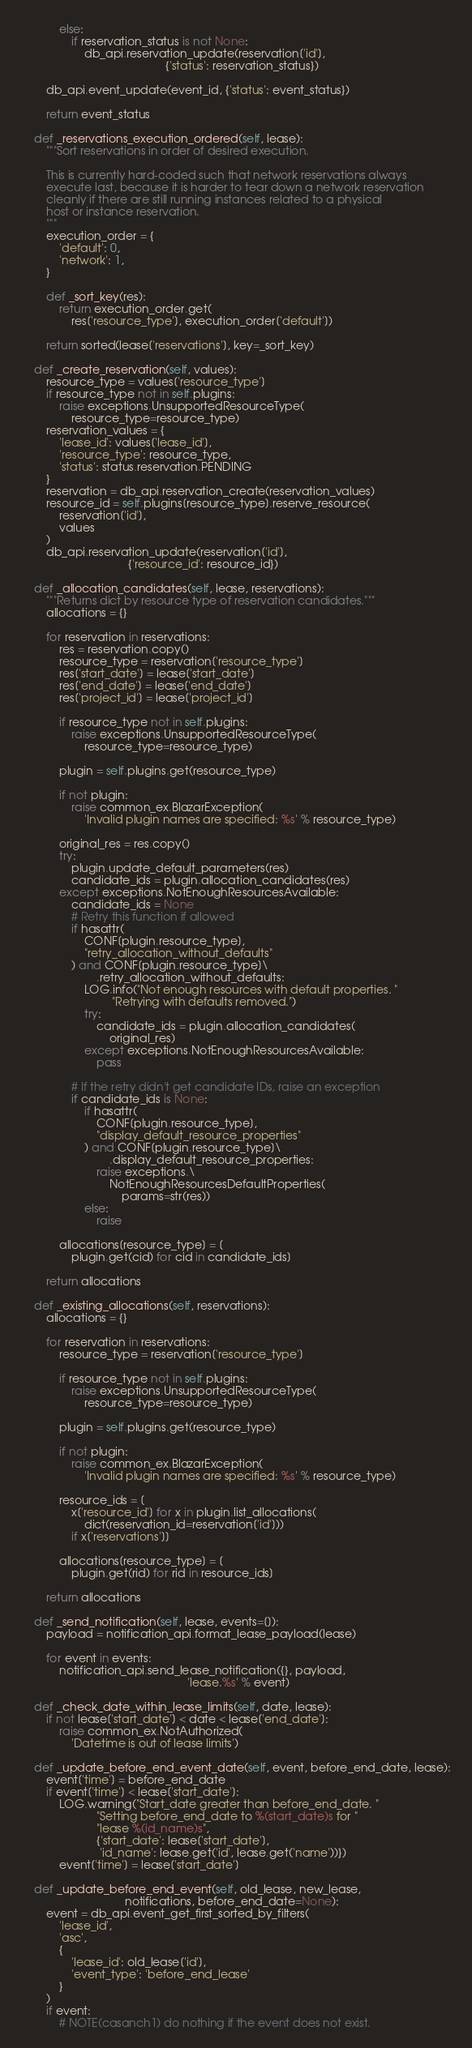Convert code to text. <code><loc_0><loc_0><loc_500><loc_500><_Python_>            else:
                if reservation_status is not None:
                    db_api.reservation_update(reservation['id'],
                                              {'status': reservation_status})

        db_api.event_update(event_id, {'status': event_status})

        return event_status

    def _reservations_execution_ordered(self, lease):
        """Sort reservations in order of desired execution.

        This is currently hard-coded such that network reservations always
        execute last, because it is harder to tear down a network reservation
        cleanly if there are still running instances related to a physical
        host or instance reservation.
        """
        execution_order = {
            'default': 0,
            'network': 1,
        }

        def _sort_key(res):
            return execution_order.get(
                res['resource_type'], execution_order['default'])

        return sorted(lease['reservations'], key=_sort_key)

    def _create_reservation(self, values):
        resource_type = values['resource_type']
        if resource_type not in self.plugins:
            raise exceptions.UnsupportedResourceType(
                resource_type=resource_type)
        reservation_values = {
            'lease_id': values['lease_id'],
            'resource_type': resource_type,
            'status': status.reservation.PENDING
        }
        reservation = db_api.reservation_create(reservation_values)
        resource_id = self.plugins[resource_type].reserve_resource(
            reservation['id'],
            values
        )
        db_api.reservation_update(reservation['id'],
                                  {'resource_id': resource_id})

    def _allocation_candidates(self, lease, reservations):
        """Returns dict by resource type of reservation candidates."""
        allocations = {}

        for reservation in reservations:
            res = reservation.copy()
            resource_type = reservation['resource_type']
            res['start_date'] = lease['start_date']
            res['end_date'] = lease['end_date']
            res['project_id'] = lease['project_id']

            if resource_type not in self.plugins:
                raise exceptions.UnsupportedResourceType(
                    resource_type=resource_type)

            plugin = self.plugins.get(resource_type)

            if not plugin:
                raise common_ex.BlazarException(
                    'Invalid plugin names are specified: %s' % resource_type)

            original_res = res.copy()
            try:
                plugin.update_default_parameters(res)
                candidate_ids = plugin.allocation_candidates(res)
            except exceptions.NotEnoughResourcesAvailable:
                candidate_ids = None
                # Retry this function if allowed
                if hasattr(
                    CONF[plugin.resource_type],
                    "retry_allocation_without_defaults"
                ) and CONF[plugin.resource_type]\
                        .retry_allocation_without_defaults:
                    LOG.info("Not enough resources with default properties. "
                             "Retrying with defaults removed.")
                    try:
                        candidate_ids = plugin.allocation_candidates(
                            original_res)
                    except exceptions.NotEnoughResourcesAvailable:
                        pass

                # If the retry didn't get candidate IDs, raise an exception
                if candidate_ids is None:
                    if hasattr(
                        CONF[plugin.resource_type],
                        "display_default_resource_properties"
                    ) and CONF[plugin.resource_type]\
                            .display_default_resource_properties:
                        raise exceptions.\
                            NotEnoughResourcesDefaultProperties(
                                params=str(res))
                    else:
                        raise

            allocations[resource_type] = [
                plugin.get(cid) for cid in candidate_ids]

        return allocations

    def _existing_allocations(self, reservations):
        allocations = {}

        for reservation in reservations:
            resource_type = reservation['resource_type']

            if resource_type not in self.plugins:
                raise exceptions.UnsupportedResourceType(
                    resource_type=resource_type)

            plugin = self.plugins.get(resource_type)

            if not plugin:
                raise common_ex.BlazarException(
                    'Invalid plugin names are specified: %s' % resource_type)

            resource_ids = [
                x['resource_id'] for x in plugin.list_allocations(
                    dict(reservation_id=reservation['id']))
                if x['reservations']]

            allocations[resource_type] = [
                plugin.get(rid) for rid in resource_ids]

        return allocations

    def _send_notification(self, lease, events=[]):
        payload = notification_api.format_lease_payload(lease)

        for event in events:
            notification_api.send_lease_notification({}, payload,
                                                     'lease.%s' % event)

    def _check_date_within_lease_limits(self, date, lease):
        if not lease['start_date'] < date < lease['end_date']:
            raise common_ex.NotAuthorized(
                'Datetime is out of lease limits')

    def _update_before_end_event_date(self, event, before_end_date, lease):
        event['time'] = before_end_date
        if event['time'] < lease['start_date']:
            LOG.warning("Start_date greater than before_end_date. "
                        "Setting before_end_date to %(start_date)s for "
                        "lease %(id_name)s",
                        {'start_date': lease['start_date'],
                         'id_name': lease.get('id', lease.get('name'))})
            event['time'] = lease['start_date']

    def _update_before_end_event(self, old_lease, new_lease,
                                 notifications, before_end_date=None):
        event = db_api.event_get_first_sorted_by_filters(
            'lease_id',
            'asc',
            {
                'lease_id': old_lease['id'],
                'event_type': 'before_end_lease'
            }
        )
        if event:
            # NOTE(casanch1) do nothing if the event does not exist.</code> 